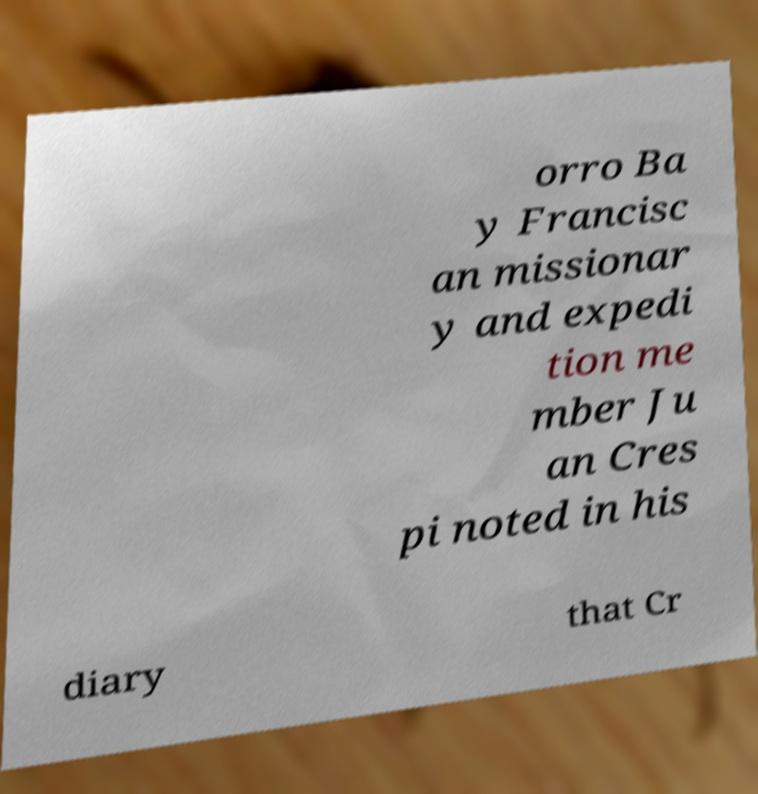I need the written content from this picture converted into text. Can you do that? orro Ba y Francisc an missionar y and expedi tion me mber Ju an Cres pi noted in his diary that Cr 